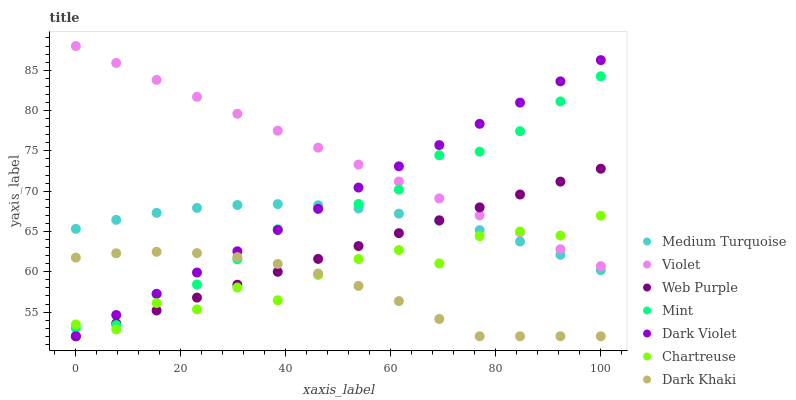Does Dark Khaki have the minimum area under the curve?
Answer yes or no. Yes. Does Violet have the maximum area under the curve?
Answer yes or no. Yes. Does Dark Violet have the minimum area under the curve?
Answer yes or no. No. Does Dark Violet have the maximum area under the curve?
Answer yes or no. No. Is Web Purple the smoothest?
Answer yes or no. Yes. Is Chartreuse the roughest?
Answer yes or no. Yes. Is Dark Violet the smoothest?
Answer yes or no. No. Is Dark Violet the roughest?
Answer yes or no. No. Does Web Purple have the lowest value?
Answer yes or no. Yes. Does Chartreuse have the lowest value?
Answer yes or no. No. Does Violet have the highest value?
Answer yes or no. Yes. Does Dark Violet have the highest value?
Answer yes or no. No. Is Medium Turquoise less than Violet?
Answer yes or no. Yes. Is Medium Turquoise greater than Dark Khaki?
Answer yes or no. Yes. Does Dark Violet intersect Violet?
Answer yes or no. Yes. Is Dark Violet less than Violet?
Answer yes or no. No. Is Dark Violet greater than Violet?
Answer yes or no. No. Does Medium Turquoise intersect Violet?
Answer yes or no. No. 